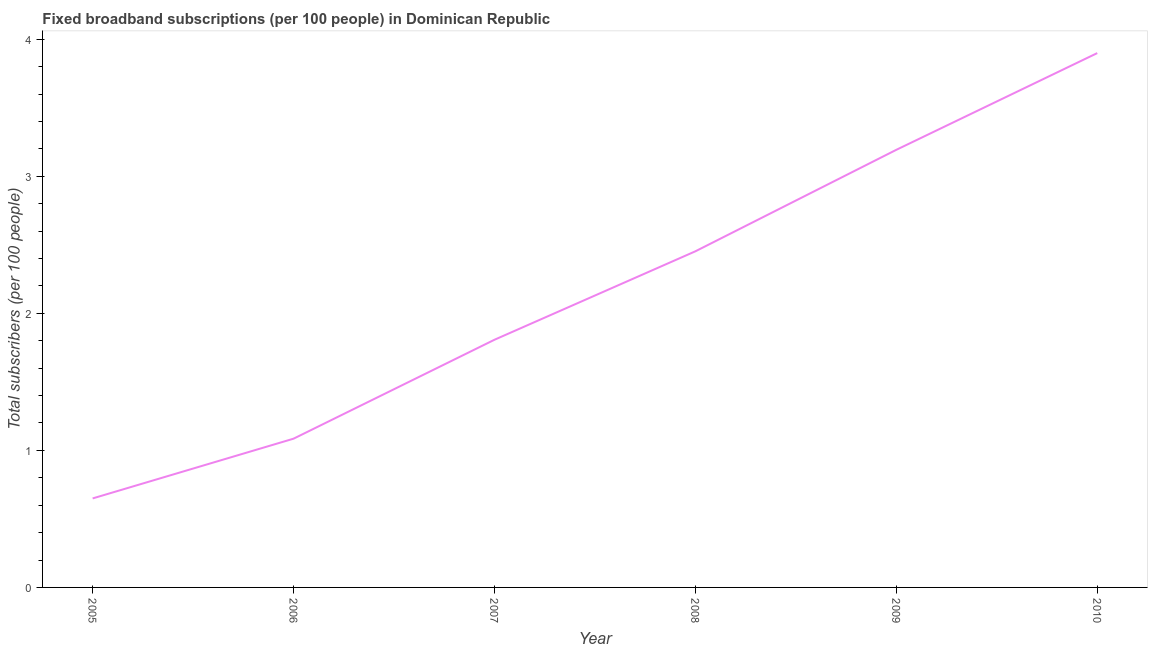What is the total number of fixed broadband subscriptions in 2010?
Your answer should be compact. 3.9. Across all years, what is the maximum total number of fixed broadband subscriptions?
Give a very brief answer. 3.9. Across all years, what is the minimum total number of fixed broadband subscriptions?
Give a very brief answer. 0.65. In which year was the total number of fixed broadband subscriptions maximum?
Your response must be concise. 2010. What is the sum of the total number of fixed broadband subscriptions?
Provide a succinct answer. 13.09. What is the difference between the total number of fixed broadband subscriptions in 2008 and 2009?
Ensure brevity in your answer.  -0.74. What is the average total number of fixed broadband subscriptions per year?
Provide a short and direct response. 2.18. What is the median total number of fixed broadband subscriptions?
Ensure brevity in your answer.  2.13. Do a majority of the years between 2009 and 2006 (inclusive) have total number of fixed broadband subscriptions greater than 2.8 ?
Offer a terse response. Yes. What is the ratio of the total number of fixed broadband subscriptions in 2009 to that in 2010?
Keep it short and to the point. 0.82. Is the difference between the total number of fixed broadband subscriptions in 2005 and 2006 greater than the difference between any two years?
Your response must be concise. No. What is the difference between the highest and the second highest total number of fixed broadband subscriptions?
Your response must be concise. 0.71. What is the difference between the highest and the lowest total number of fixed broadband subscriptions?
Your answer should be compact. 3.25. In how many years, is the total number of fixed broadband subscriptions greater than the average total number of fixed broadband subscriptions taken over all years?
Provide a short and direct response. 3. Does the total number of fixed broadband subscriptions monotonically increase over the years?
Your response must be concise. Yes. How many lines are there?
Your response must be concise. 1. What is the title of the graph?
Ensure brevity in your answer.  Fixed broadband subscriptions (per 100 people) in Dominican Republic. What is the label or title of the X-axis?
Your answer should be compact. Year. What is the label or title of the Y-axis?
Your response must be concise. Total subscribers (per 100 people). What is the Total subscribers (per 100 people) in 2005?
Ensure brevity in your answer.  0.65. What is the Total subscribers (per 100 people) in 2006?
Your answer should be compact. 1.09. What is the Total subscribers (per 100 people) in 2007?
Ensure brevity in your answer.  1.81. What is the Total subscribers (per 100 people) in 2008?
Your answer should be compact. 2.45. What is the Total subscribers (per 100 people) in 2009?
Offer a terse response. 3.19. What is the Total subscribers (per 100 people) in 2010?
Provide a short and direct response. 3.9. What is the difference between the Total subscribers (per 100 people) in 2005 and 2006?
Make the answer very short. -0.44. What is the difference between the Total subscribers (per 100 people) in 2005 and 2007?
Give a very brief answer. -1.16. What is the difference between the Total subscribers (per 100 people) in 2005 and 2008?
Offer a terse response. -1.8. What is the difference between the Total subscribers (per 100 people) in 2005 and 2009?
Your answer should be compact. -2.54. What is the difference between the Total subscribers (per 100 people) in 2005 and 2010?
Give a very brief answer. -3.25. What is the difference between the Total subscribers (per 100 people) in 2006 and 2007?
Offer a terse response. -0.72. What is the difference between the Total subscribers (per 100 people) in 2006 and 2008?
Ensure brevity in your answer.  -1.37. What is the difference between the Total subscribers (per 100 people) in 2006 and 2009?
Give a very brief answer. -2.11. What is the difference between the Total subscribers (per 100 people) in 2006 and 2010?
Offer a very short reply. -2.81. What is the difference between the Total subscribers (per 100 people) in 2007 and 2008?
Provide a succinct answer. -0.65. What is the difference between the Total subscribers (per 100 people) in 2007 and 2009?
Provide a short and direct response. -1.39. What is the difference between the Total subscribers (per 100 people) in 2007 and 2010?
Keep it short and to the point. -2.09. What is the difference between the Total subscribers (per 100 people) in 2008 and 2009?
Make the answer very short. -0.74. What is the difference between the Total subscribers (per 100 people) in 2008 and 2010?
Your answer should be compact. -1.45. What is the difference between the Total subscribers (per 100 people) in 2009 and 2010?
Your answer should be compact. -0.71. What is the ratio of the Total subscribers (per 100 people) in 2005 to that in 2006?
Provide a succinct answer. 0.6. What is the ratio of the Total subscribers (per 100 people) in 2005 to that in 2007?
Your answer should be very brief. 0.36. What is the ratio of the Total subscribers (per 100 people) in 2005 to that in 2008?
Provide a short and direct response. 0.27. What is the ratio of the Total subscribers (per 100 people) in 2005 to that in 2009?
Make the answer very short. 0.2. What is the ratio of the Total subscribers (per 100 people) in 2005 to that in 2010?
Give a very brief answer. 0.17. What is the ratio of the Total subscribers (per 100 people) in 2006 to that in 2007?
Offer a very short reply. 0.6. What is the ratio of the Total subscribers (per 100 people) in 2006 to that in 2008?
Ensure brevity in your answer.  0.44. What is the ratio of the Total subscribers (per 100 people) in 2006 to that in 2009?
Offer a very short reply. 0.34. What is the ratio of the Total subscribers (per 100 people) in 2006 to that in 2010?
Provide a succinct answer. 0.28. What is the ratio of the Total subscribers (per 100 people) in 2007 to that in 2008?
Your response must be concise. 0.74. What is the ratio of the Total subscribers (per 100 people) in 2007 to that in 2009?
Your response must be concise. 0.57. What is the ratio of the Total subscribers (per 100 people) in 2007 to that in 2010?
Provide a short and direct response. 0.46. What is the ratio of the Total subscribers (per 100 people) in 2008 to that in 2009?
Provide a short and direct response. 0.77. What is the ratio of the Total subscribers (per 100 people) in 2008 to that in 2010?
Your response must be concise. 0.63. What is the ratio of the Total subscribers (per 100 people) in 2009 to that in 2010?
Your response must be concise. 0.82. 